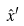Convert formula to latex. <formula><loc_0><loc_0><loc_500><loc_500>\hat { x } ^ { \prime }</formula> 